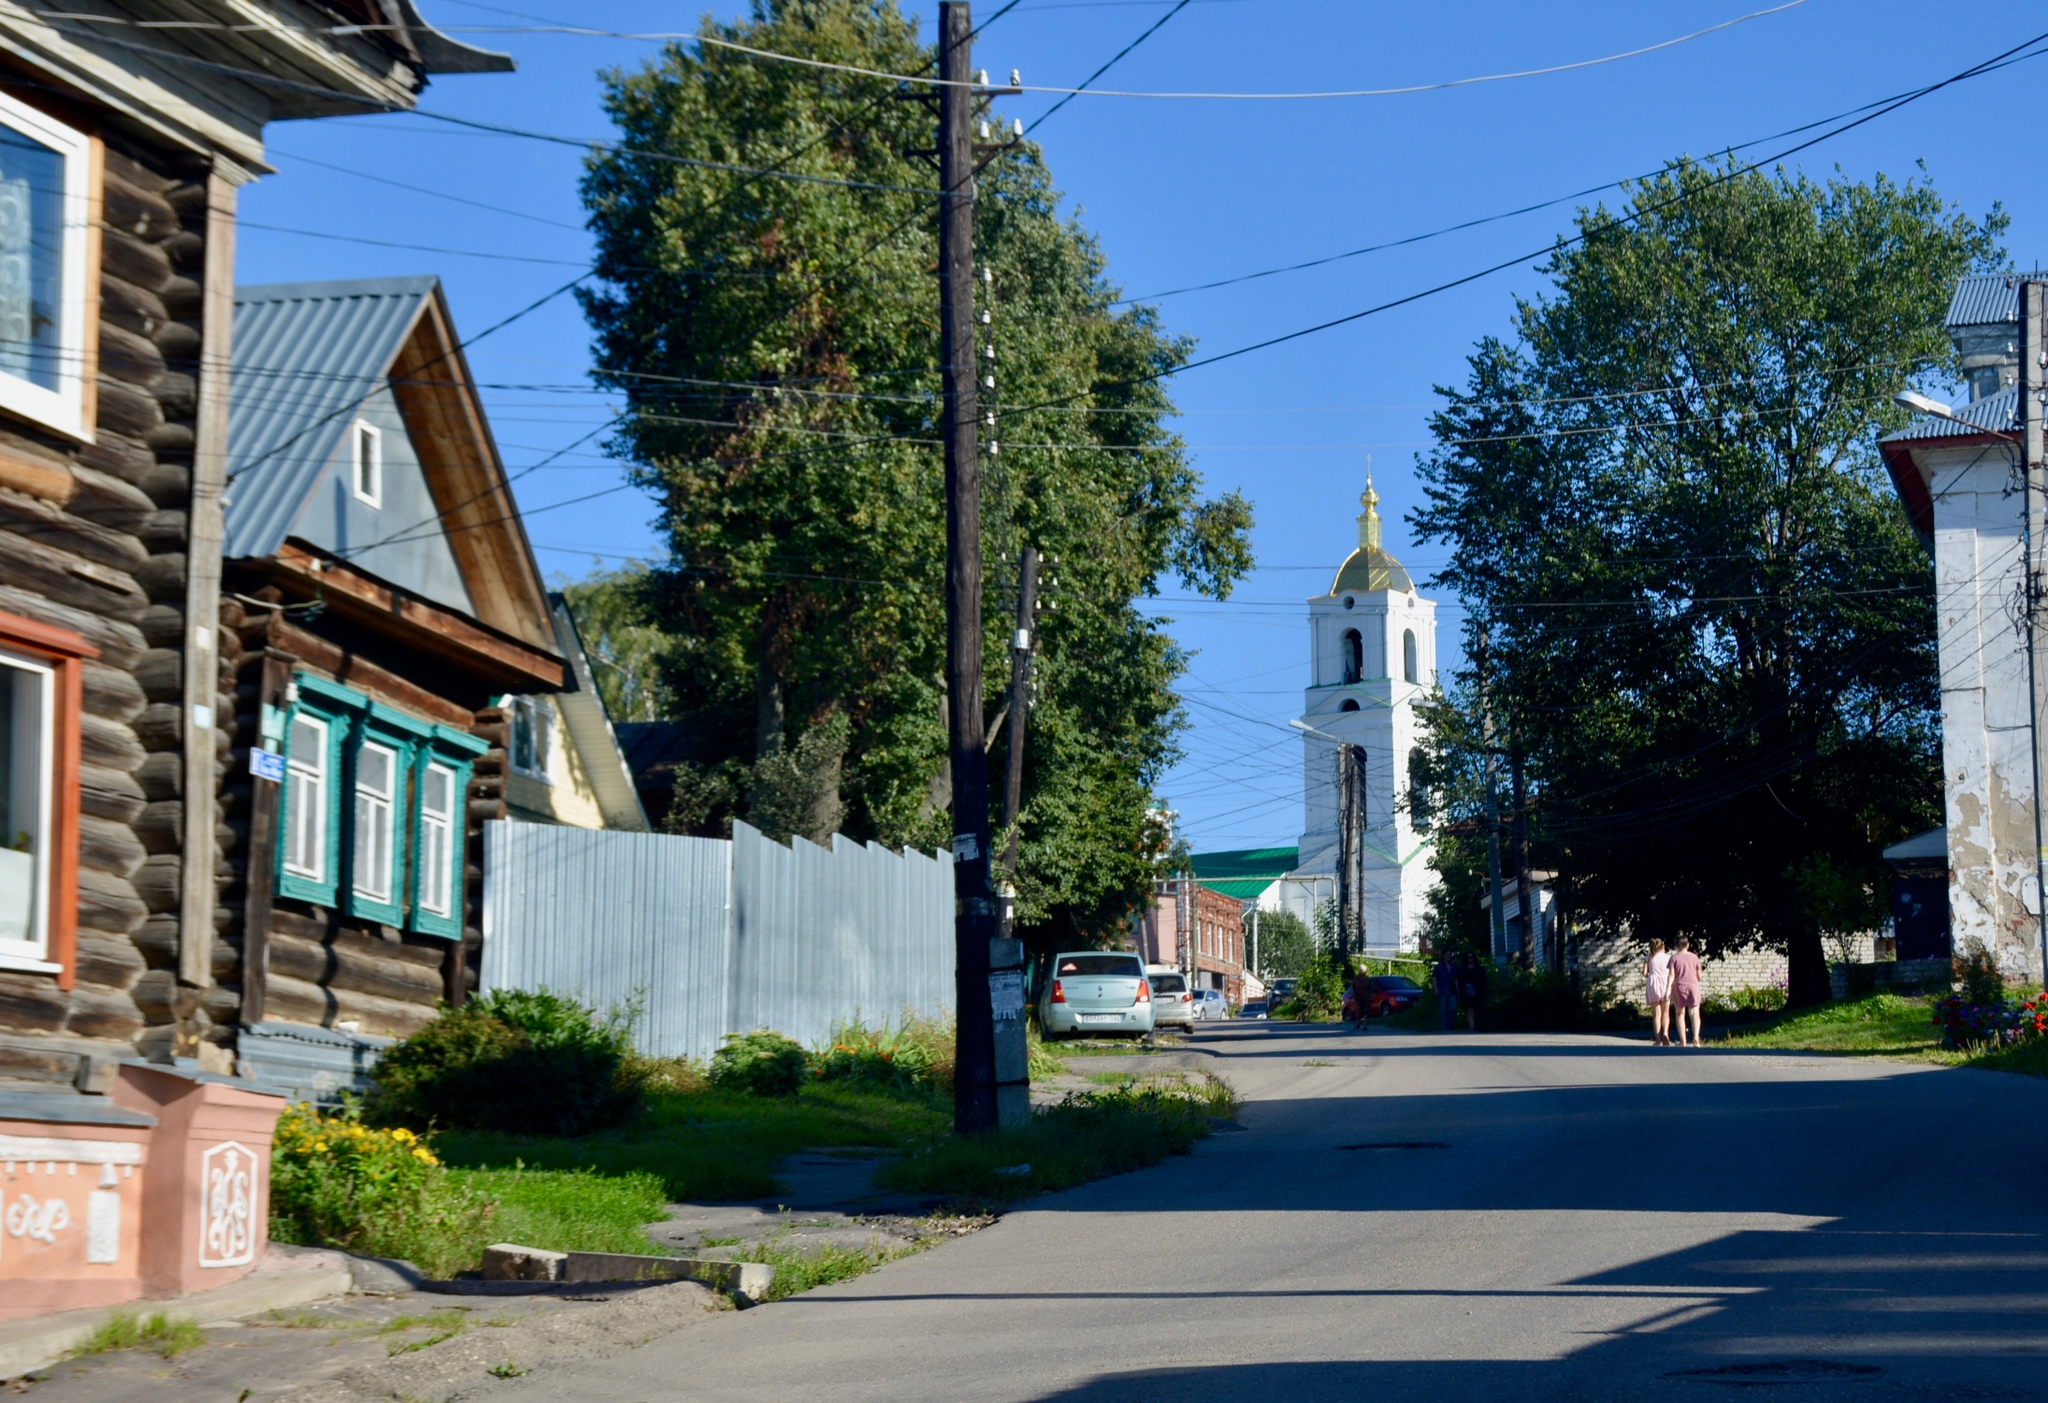What are the key elements in this picture? The image distinctly portrays a serene town scene, characterized by traditional wooden houses with colorful window frames, lining a subdued street. At the heart of the scene stands a striking white church tower with a gold dome, soaring against a vivid blue sky, symbolizing perhaps a cultural or spiritual beacon for the community. The town's landscape integrates well with natural elements like lush trees which add vitality and a sense of calm to the town, while a few parked cars and pedestrians suggest daily life activities. This blend of architecture and natural beauty, along with signs of daily life, encapsulates the essence of small-town charm and simplicity. 